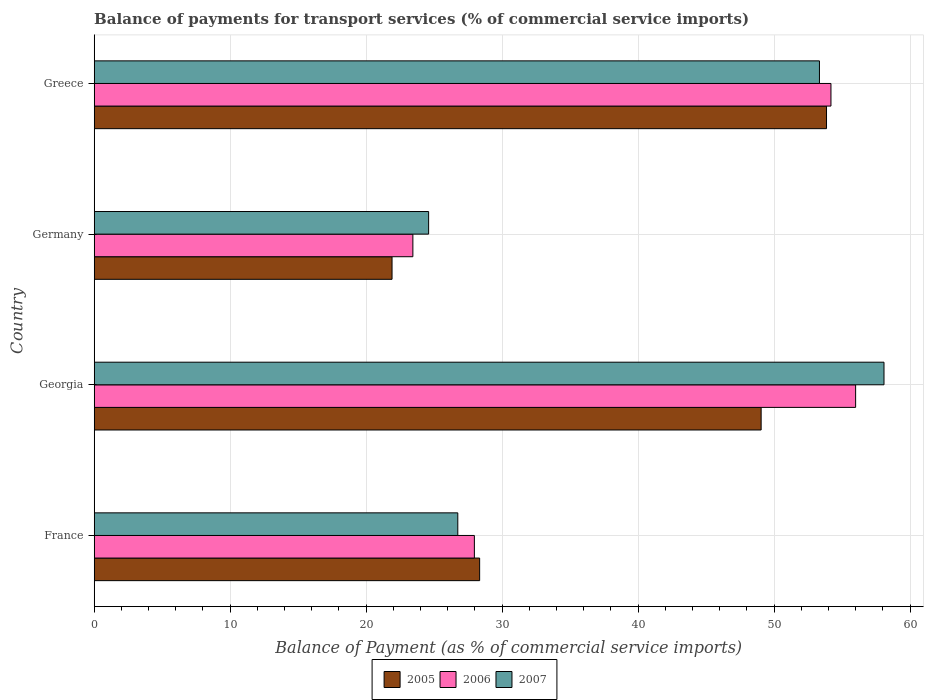Are the number of bars on each tick of the Y-axis equal?
Ensure brevity in your answer.  Yes. How many bars are there on the 3rd tick from the top?
Your answer should be very brief. 3. How many bars are there on the 4th tick from the bottom?
Keep it short and to the point. 3. What is the label of the 3rd group of bars from the top?
Make the answer very short. Georgia. In how many cases, is the number of bars for a given country not equal to the number of legend labels?
Keep it short and to the point. 0. What is the balance of payments for transport services in 2006 in Georgia?
Provide a short and direct response. 56. Across all countries, what is the maximum balance of payments for transport services in 2006?
Provide a short and direct response. 56. Across all countries, what is the minimum balance of payments for transport services in 2005?
Your answer should be compact. 21.91. In which country was the balance of payments for transport services in 2006 maximum?
Offer a terse response. Georgia. What is the total balance of payments for transport services in 2007 in the graph?
Offer a terse response. 162.77. What is the difference between the balance of payments for transport services in 2005 in Germany and that in Greece?
Offer a terse response. -31.95. What is the difference between the balance of payments for transport services in 2007 in Greece and the balance of payments for transport services in 2005 in France?
Ensure brevity in your answer.  24.99. What is the average balance of payments for transport services in 2005 per country?
Provide a short and direct response. 38.29. What is the difference between the balance of payments for transport services in 2005 and balance of payments for transport services in 2006 in France?
Provide a succinct answer. 0.39. What is the ratio of the balance of payments for transport services in 2007 in Georgia to that in Germany?
Offer a terse response. 2.36. Is the difference between the balance of payments for transport services in 2005 in Germany and Greece greater than the difference between the balance of payments for transport services in 2006 in Germany and Greece?
Make the answer very short. No. What is the difference between the highest and the second highest balance of payments for transport services in 2007?
Offer a terse response. 4.75. What is the difference between the highest and the lowest balance of payments for transport services in 2006?
Give a very brief answer. 32.56. In how many countries, is the balance of payments for transport services in 2007 greater than the average balance of payments for transport services in 2007 taken over all countries?
Your answer should be compact. 2. Is the sum of the balance of payments for transport services in 2007 in France and Greece greater than the maximum balance of payments for transport services in 2005 across all countries?
Provide a short and direct response. Yes. What does the 1st bar from the top in Greece represents?
Your answer should be compact. 2007. What does the 1st bar from the bottom in Greece represents?
Your answer should be compact. 2005. Is it the case that in every country, the sum of the balance of payments for transport services in 2005 and balance of payments for transport services in 2006 is greater than the balance of payments for transport services in 2007?
Your response must be concise. Yes. How many countries are there in the graph?
Provide a succinct answer. 4. What is the difference between two consecutive major ticks on the X-axis?
Ensure brevity in your answer.  10. Are the values on the major ticks of X-axis written in scientific E-notation?
Give a very brief answer. No. What is the title of the graph?
Keep it short and to the point. Balance of payments for transport services (% of commercial service imports). What is the label or title of the X-axis?
Offer a terse response. Balance of Payment (as % of commercial service imports). What is the label or title of the Y-axis?
Your answer should be very brief. Country. What is the Balance of Payment (as % of commercial service imports) in 2005 in France?
Ensure brevity in your answer.  28.35. What is the Balance of Payment (as % of commercial service imports) of 2006 in France?
Ensure brevity in your answer.  27.96. What is the Balance of Payment (as % of commercial service imports) of 2007 in France?
Your answer should be very brief. 26.74. What is the Balance of Payment (as % of commercial service imports) in 2005 in Georgia?
Offer a very short reply. 49.05. What is the Balance of Payment (as % of commercial service imports) in 2006 in Georgia?
Ensure brevity in your answer.  56. What is the Balance of Payment (as % of commercial service imports) of 2007 in Georgia?
Offer a terse response. 58.09. What is the Balance of Payment (as % of commercial service imports) of 2005 in Germany?
Ensure brevity in your answer.  21.91. What is the Balance of Payment (as % of commercial service imports) of 2006 in Germany?
Make the answer very short. 23.44. What is the Balance of Payment (as % of commercial service imports) in 2007 in Germany?
Give a very brief answer. 24.6. What is the Balance of Payment (as % of commercial service imports) in 2005 in Greece?
Provide a succinct answer. 53.86. What is the Balance of Payment (as % of commercial service imports) of 2006 in Greece?
Give a very brief answer. 54.19. What is the Balance of Payment (as % of commercial service imports) in 2007 in Greece?
Your answer should be very brief. 53.34. Across all countries, what is the maximum Balance of Payment (as % of commercial service imports) of 2005?
Keep it short and to the point. 53.86. Across all countries, what is the maximum Balance of Payment (as % of commercial service imports) of 2006?
Provide a short and direct response. 56. Across all countries, what is the maximum Balance of Payment (as % of commercial service imports) in 2007?
Offer a terse response. 58.09. Across all countries, what is the minimum Balance of Payment (as % of commercial service imports) in 2005?
Give a very brief answer. 21.91. Across all countries, what is the minimum Balance of Payment (as % of commercial service imports) in 2006?
Provide a short and direct response. 23.44. Across all countries, what is the minimum Balance of Payment (as % of commercial service imports) of 2007?
Offer a very short reply. 24.6. What is the total Balance of Payment (as % of commercial service imports) of 2005 in the graph?
Keep it short and to the point. 153.16. What is the total Balance of Payment (as % of commercial service imports) in 2006 in the graph?
Ensure brevity in your answer.  161.58. What is the total Balance of Payment (as % of commercial service imports) of 2007 in the graph?
Offer a very short reply. 162.77. What is the difference between the Balance of Payment (as % of commercial service imports) of 2005 in France and that in Georgia?
Provide a short and direct response. -20.7. What is the difference between the Balance of Payment (as % of commercial service imports) in 2006 in France and that in Georgia?
Your answer should be very brief. -28.04. What is the difference between the Balance of Payment (as % of commercial service imports) in 2007 in France and that in Georgia?
Make the answer very short. -31.35. What is the difference between the Balance of Payment (as % of commercial service imports) in 2005 in France and that in Germany?
Offer a very short reply. 6.44. What is the difference between the Balance of Payment (as % of commercial service imports) of 2006 in France and that in Germany?
Make the answer very short. 4.52. What is the difference between the Balance of Payment (as % of commercial service imports) in 2007 in France and that in Germany?
Offer a terse response. 2.14. What is the difference between the Balance of Payment (as % of commercial service imports) in 2005 in France and that in Greece?
Your answer should be compact. -25.51. What is the difference between the Balance of Payment (as % of commercial service imports) in 2006 in France and that in Greece?
Your response must be concise. -26.23. What is the difference between the Balance of Payment (as % of commercial service imports) in 2007 in France and that in Greece?
Your answer should be compact. -26.6. What is the difference between the Balance of Payment (as % of commercial service imports) of 2005 in Georgia and that in Germany?
Offer a very short reply. 27.15. What is the difference between the Balance of Payment (as % of commercial service imports) of 2006 in Georgia and that in Germany?
Keep it short and to the point. 32.56. What is the difference between the Balance of Payment (as % of commercial service imports) of 2007 in Georgia and that in Germany?
Your answer should be very brief. 33.49. What is the difference between the Balance of Payment (as % of commercial service imports) of 2005 in Georgia and that in Greece?
Give a very brief answer. -4.81. What is the difference between the Balance of Payment (as % of commercial service imports) of 2006 in Georgia and that in Greece?
Give a very brief answer. 1.82. What is the difference between the Balance of Payment (as % of commercial service imports) of 2007 in Georgia and that in Greece?
Ensure brevity in your answer.  4.75. What is the difference between the Balance of Payment (as % of commercial service imports) of 2005 in Germany and that in Greece?
Offer a very short reply. -31.95. What is the difference between the Balance of Payment (as % of commercial service imports) in 2006 in Germany and that in Greece?
Offer a terse response. -30.75. What is the difference between the Balance of Payment (as % of commercial service imports) in 2007 in Germany and that in Greece?
Give a very brief answer. -28.74. What is the difference between the Balance of Payment (as % of commercial service imports) in 2005 in France and the Balance of Payment (as % of commercial service imports) in 2006 in Georgia?
Give a very brief answer. -27.65. What is the difference between the Balance of Payment (as % of commercial service imports) in 2005 in France and the Balance of Payment (as % of commercial service imports) in 2007 in Georgia?
Your response must be concise. -29.74. What is the difference between the Balance of Payment (as % of commercial service imports) in 2006 in France and the Balance of Payment (as % of commercial service imports) in 2007 in Georgia?
Your response must be concise. -30.13. What is the difference between the Balance of Payment (as % of commercial service imports) in 2005 in France and the Balance of Payment (as % of commercial service imports) in 2006 in Germany?
Make the answer very short. 4.91. What is the difference between the Balance of Payment (as % of commercial service imports) of 2005 in France and the Balance of Payment (as % of commercial service imports) of 2007 in Germany?
Your response must be concise. 3.75. What is the difference between the Balance of Payment (as % of commercial service imports) of 2006 in France and the Balance of Payment (as % of commercial service imports) of 2007 in Germany?
Offer a very short reply. 3.36. What is the difference between the Balance of Payment (as % of commercial service imports) of 2005 in France and the Balance of Payment (as % of commercial service imports) of 2006 in Greece?
Keep it short and to the point. -25.84. What is the difference between the Balance of Payment (as % of commercial service imports) in 2005 in France and the Balance of Payment (as % of commercial service imports) in 2007 in Greece?
Make the answer very short. -24.99. What is the difference between the Balance of Payment (as % of commercial service imports) of 2006 in France and the Balance of Payment (as % of commercial service imports) of 2007 in Greece?
Provide a succinct answer. -25.38. What is the difference between the Balance of Payment (as % of commercial service imports) in 2005 in Georgia and the Balance of Payment (as % of commercial service imports) in 2006 in Germany?
Keep it short and to the point. 25.61. What is the difference between the Balance of Payment (as % of commercial service imports) in 2005 in Georgia and the Balance of Payment (as % of commercial service imports) in 2007 in Germany?
Offer a very short reply. 24.46. What is the difference between the Balance of Payment (as % of commercial service imports) of 2006 in Georgia and the Balance of Payment (as % of commercial service imports) of 2007 in Germany?
Give a very brief answer. 31.4. What is the difference between the Balance of Payment (as % of commercial service imports) of 2005 in Georgia and the Balance of Payment (as % of commercial service imports) of 2006 in Greece?
Provide a short and direct response. -5.13. What is the difference between the Balance of Payment (as % of commercial service imports) of 2005 in Georgia and the Balance of Payment (as % of commercial service imports) of 2007 in Greece?
Give a very brief answer. -4.29. What is the difference between the Balance of Payment (as % of commercial service imports) of 2006 in Georgia and the Balance of Payment (as % of commercial service imports) of 2007 in Greece?
Ensure brevity in your answer.  2.66. What is the difference between the Balance of Payment (as % of commercial service imports) of 2005 in Germany and the Balance of Payment (as % of commercial service imports) of 2006 in Greece?
Your answer should be compact. -32.28. What is the difference between the Balance of Payment (as % of commercial service imports) of 2005 in Germany and the Balance of Payment (as % of commercial service imports) of 2007 in Greece?
Your response must be concise. -31.43. What is the difference between the Balance of Payment (as % of commercial service imports) in 2006 in Germany and the Balance of Payment (as % of commercial service imports) in 2007 in Greece?
Provide a succinct answer. -29.9. What is the average Balance of Payment (as % of commercial service imports) of 2005 per country?
Ensure brevity in your answer.  38.29. What is the average Balance of Payment (as % of commercial service imports) of 2006 per country?
Offer a very short reply. 40.4. What is the average Balance of Payment (as % of commercial service imports) of 2007 per country?
Make the answer very short. 40.69. What is the difference between the Balance of Payment (as % of commercial service imports) in 2005 and Balance of Payment (as % of commercial service imports) in 2006 in France?
Provide a short and direct response. 0.39. What is the difference between the Balance of Payment (as % of commercial service imports) of 2005 and Balance of Payment (as % of commercial service imports) of 2007 in France?
Keep it short and to the point. 1.61. What is the difference between the Balance of Payment (as % of commercial service imports) in 2006 and Balance of Payment (as % of commercial service imports) in 2007 in France?
Keep it short and to the point. 1.22. What is the difference between the Balance of Payment (as % of commercial service imports) of 2005 and Balance of Payment (as % of commercial service imports) of 2006 in Georgia?
Provide a succinct answer. -6.95. What is the difference between the Balance of Payment (as % of commercial service imports) in 2005 and Balance of Payment (as % of commercial service imports) in 2007 in Georgia?
Give a very brief answer. -9.04. What is the difference between the Balance of Payment (as % of commercial service imports) in 2006 and Balance of Payment (as % of commercial service imports) in 2007 in Georgia?
Make the answer very short. -2.09. What is the difference between the Balance of Payment (as % of commercial service imports) in 2005 and Balance of Payment (as % of commercial service imports) in 2006 in Germany?
Ensure brevity in your answer.  -1.53. What is the difference between the Balance of Payment (as % of commercial service imports) of 2005 and Balance of Payment (as % of commercial service imports) of 2007 in Germany?
Provide a short and direct response. -2.69. What is the difference between the Balance of Payment (as % of commercial service imports) in 2006 and Balance of Payment (as % of commercial service imports) in 2007 in Germany?
Offer a terse response. -1.16. What is the difference between the Balance of Payment (as % of commercial service imports) in 2005 and Balance of Payment (as % of commercial service imports) in 2006 in Greece?
Make the answer very short. -0.33. What is the difference between the Balance of Payment (as % of commercial service imports) of 2005 and Balance of Payment (as % of commercial service imports) of 2007 in Greece?
Give a very brief answer. 0.52. What is the difference between the Balance of Payment (as % of commercial service imports) of 2006 and Balance of Payment (as % of commercial service imports) of 2007 in Greece?
Make the answer very short. 0.85. What is the ratio of the Balance of Payment (as % of commercial service imports) of 2005 in France to that in Georgia?
Your answer should be compact. 0.58. What is the ratio of the Balance of Payment (as % of commercial service imports) of 2006 in France to that in Georgia?
Offer a terse response. 0.5. What is the ratio of the Balance of Payment (as % of commercial service imports) of 2007 in France to that in Georgia?
Offer a terse response. 0.46. What is the ratio of the Balance of Payment (as % of commercial service imports) of 2005 in France to that in Germany?
Provide a short and direct response. 1.29. What is the ratio of the Balance of Payment (as % of commercial service imports) of 2006 in France to that in Germany?
Offer a terse response. 1.19. What is the ratio of the Balance of Payment (as % of commercial service imports) in 2007 in France to that in Germany?
Make the answer very short. 1.09. What is the ratio of the Balance of Payment (as % of commercial service imports) in 2005 in France to that in Greece?
Make the answer very short. 0.53. What is the ratio of the Balance of Payment (as % of commercial service imports) in 2006 in France to that in Greece?
Give a very brief answer. 0.52. What is the ratio of the Balance of Payment (as % of commercial service imports) of 2007 in France to that in Greece?
Give a very brief answer. 0.5. What is the ratio of the Balance of Payment (as % of commercial service imports) in 2005 in Georgia to that in Germany?
Your answer should be compact. 2.24. What is the ratio of the Balance of Payment (as % of commercial service imports) in 2006 in Georgia to that in Germany?
Ensure brevity in your answer.  2.39. What is the ratio of the Balance of Payment (as % of commercial service imports) of 2007 in Georgia to that in Germany?
Provide a short and direct response. 2.36. What is the ratio of the Balance of Payment (as % of commercial service imports) in 2005 in Georgia to that in Greece?
Your answer should be compact. 0.91. What is the ratio of the Balance of Payment (as % of commercial service imports) of 2006 in Georgia to that in Greece?
Ensure brevity in your answer.  1.03. What is the ratio of the Balance of Payment (as % of commercial service imports) in 2007 in Georgia to that in Greece?
Keep it short and to the point. 1.09. What is the ratio of the Balance of Payment (as % of commercial service imports) of 2005 in Germany to that in Greece?
Your response must be concise. 0.41. What is the ratio of the Balance of Payment (as % of commercial service imports) in 2006 in Germany to that in Greece?
Provide a succinct answer. 0.43. What is the ratio of the Balance of Payment (as % of commercial service imports) in 2007 in Germany to that in Greece?
Keep it short and to the point. 0.46. What is the difference between the highest and the second highest Balance of Payment (as % of commercial service imports) of 2005?
Your response must be concise. 4.81. What is the difference between the highest and the second highest Balance of Payment (as % of commercial service imports) of 2006?
Your response must be concise. 1.82. What is the difference between the highest and the second highest Balance of Payment (as % of commercial service imports) in 2007?
Provide a short and direct response. 4.75. What is the difference between the highest and the lowest Balance of Payment (as % of commercial service imports) in 2005?
Offer a very short reply. 31.95. What is the difference between the highest and the lowest Balance of Payment (as % of commercial service imports) of 2006?
Offer a terse response. 32.56. What is the difference between the highest and the lowest Balance of Payment (as % of commercial service imports) of 2007?
Provide a succinct answer. 33.49. 